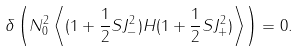<formula> <loc_0><loc_0><loc_500><loc_500>\delta \left ( N _ { 0 } ^ { 2 } \left \langle ( 1 + \frac { 1 } { 2 } S J _ { - } ^ { 2 } ) H ( 1 + \frac { 1 } { 2 } S J _ { + } ^ { 2 } ) \right \rangle \right ) = 0 .</formula> 